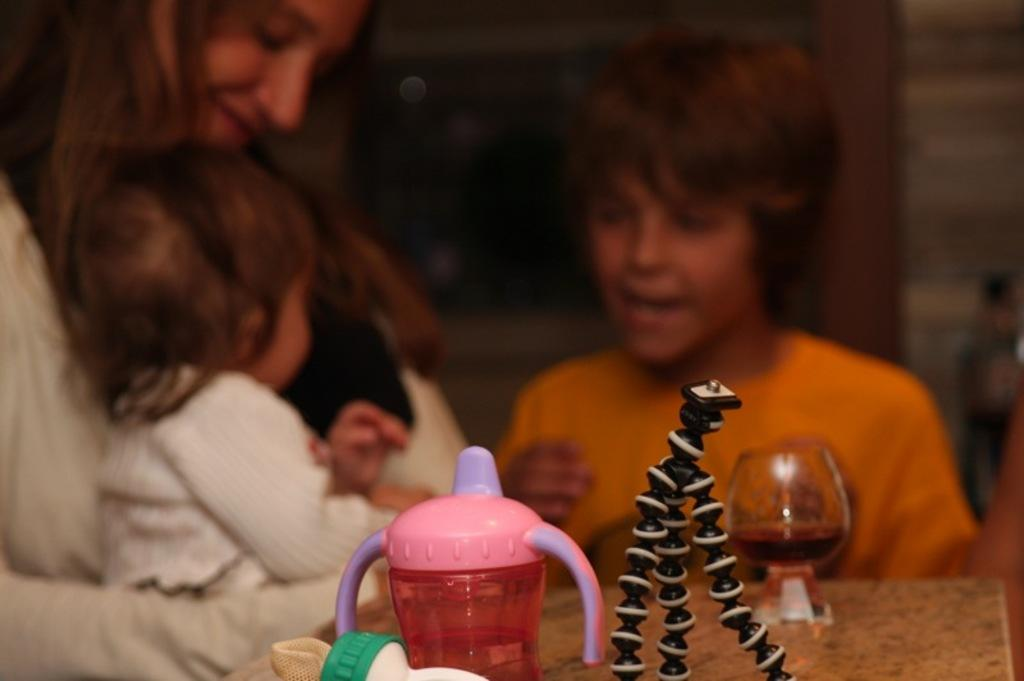What objects are in the foreground of the image? There is a glass and a water bottle in the foreground of the image, along with other objects. Can you describe the other objects in the foreground? Unfortunately, the provided facts do not specify the other objects in the foreground. What can be seen in the background of the image? There are people in the background of the image. What type of peace symbol can be seen in the image? There is no peace symbol present in the image. How many ants are visible on the glass in the image? There are no ants visible on the glass in the image. 